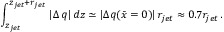Convert formula to latex. <formula><loc_0><loc_0><loc_500><loc_500>\int _ { z _ { j e t } } ^ { z _ { j e t } + r _ { j e t } } \, | \Delta \, q | \, d z \simeq | \Delta q ( \bar { x } = 0 ) | \, r _ { j e t } \approx 0 . 7 r _ { j e t } \, .</formula> 